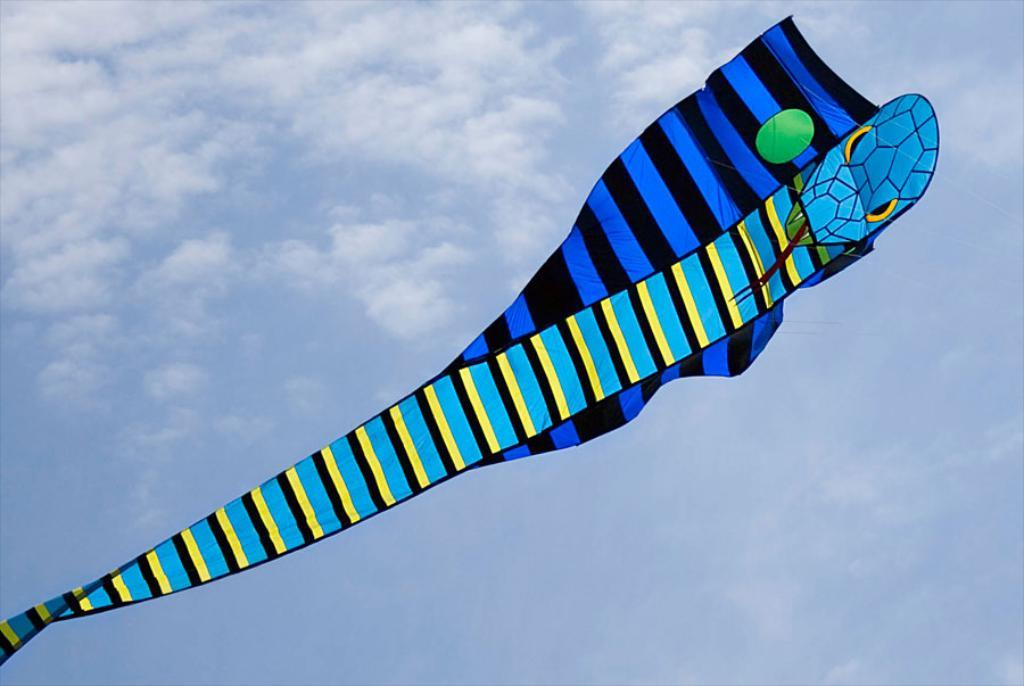What is the main object in the image? There is a kite in the image. How is the kite being controlled or held in the image? The kite is flying with the help of a string. What is the color and condition of the sky in the image? The sky is blue and cloudy in the image. Can you see any corks floating in the sky in the image? There are no corks visible in the image; the main object is a kite flying with the help of a string. Are there any yaks grazing in the background of the image? There are no yaks present in the image; the focus is on the kite and the sky. 